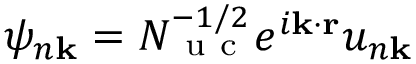<formula> <loc_0><loc_0><loc_500><loc_500>\psi _ { n \mathbf k } = N _ { u c } ^ { - 1 / 2 } e ^ { i \mathbf k \cdot \mathbf r } u _ { n \mathbf k }</formula> 